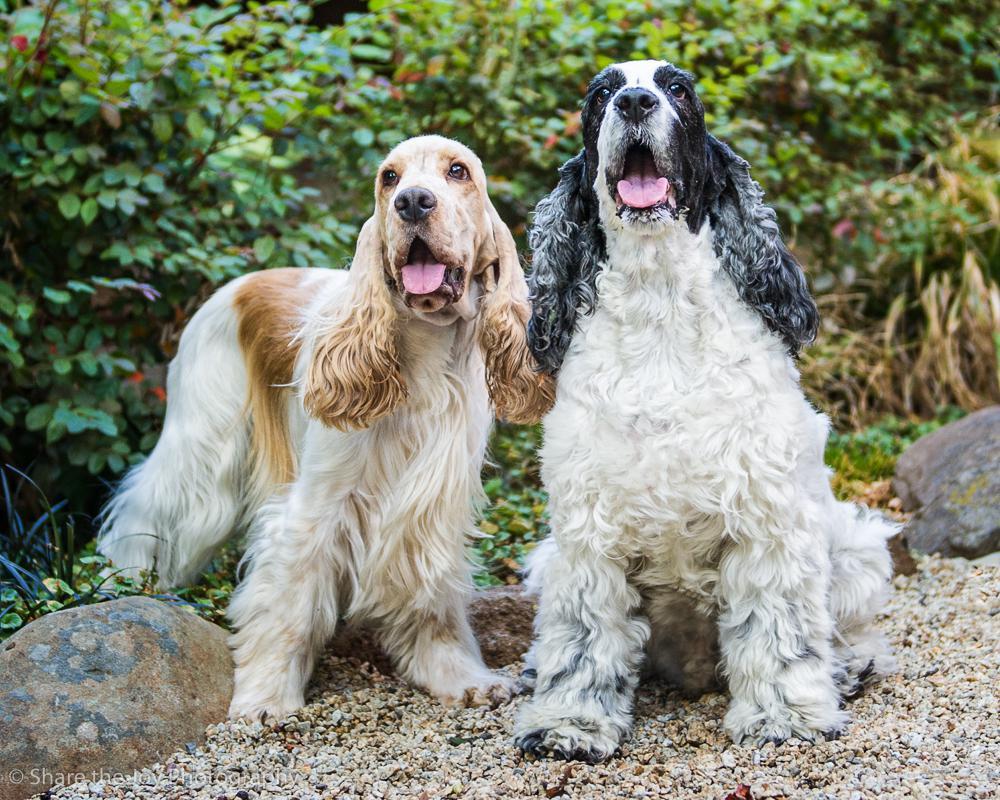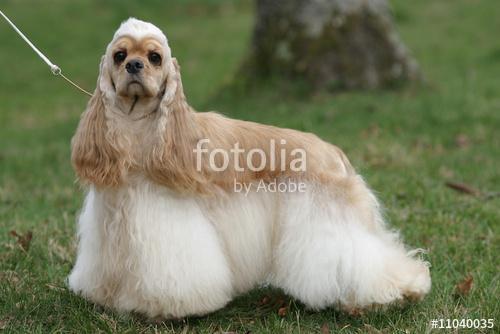The first image is the image on the left, the second image is the image on the right. Considering the images on both sides, is "There are two dogs shown in total" valid? Answer yes or no. No. The first image is the image on the left, the second image is the image on the right. Assess this claim about the two images: "The right photo shows a dog standing in the grass.". Correct or not? Answer yes or no. Yes. 